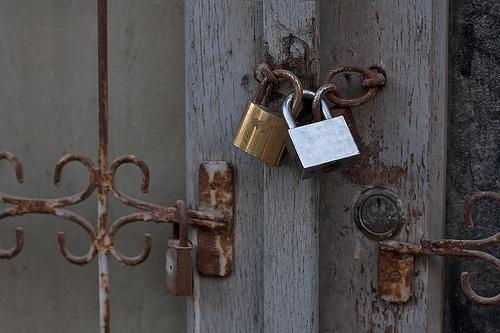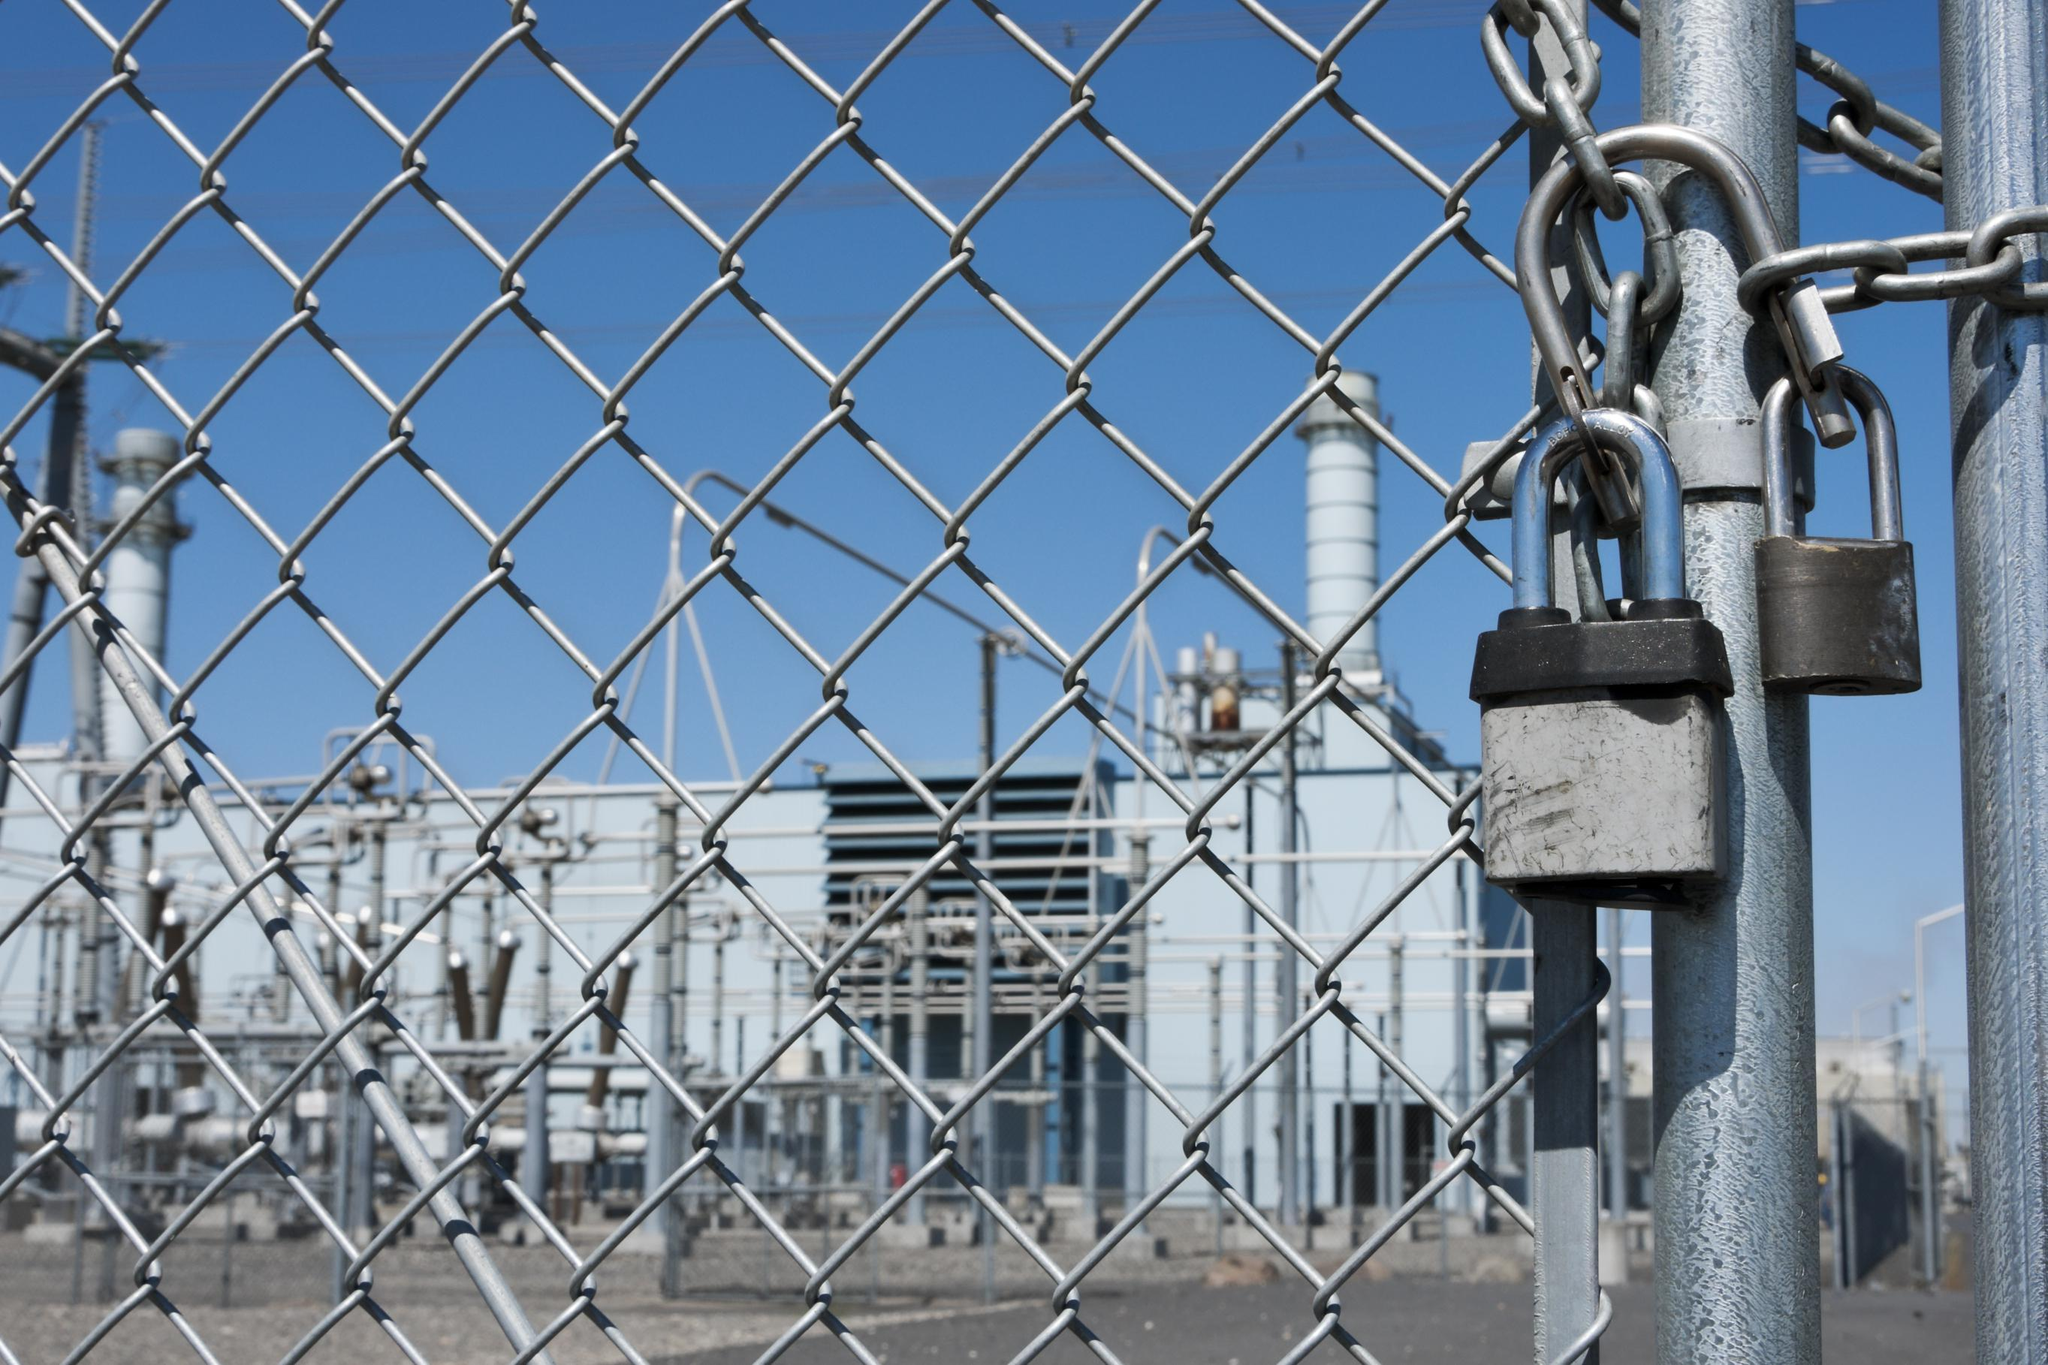The first image is the image on the left, the second image is the image on the right. Analyze the images presented: Is the assertion "At least one image contains no less than six locks." valid? Answer yes or no. No. 